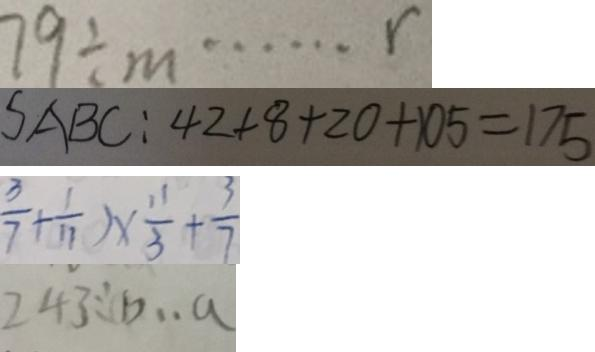Convert formula to latex. <formula><loc_0><loc_0><loc_500><loc_500>7 9 \div m \cdots r 
 S A B C : 4 2 + 8 + 2 0 + 1 0 5 = 1 7 5 
 \frac { 3 } { 7 } + \frac { 1 } { 1 1 } ) \times \frac { 1 1 } { 3 } + \frac { 3 } { 7 } 
 2 4 3 \div b \cdot a</formula> 